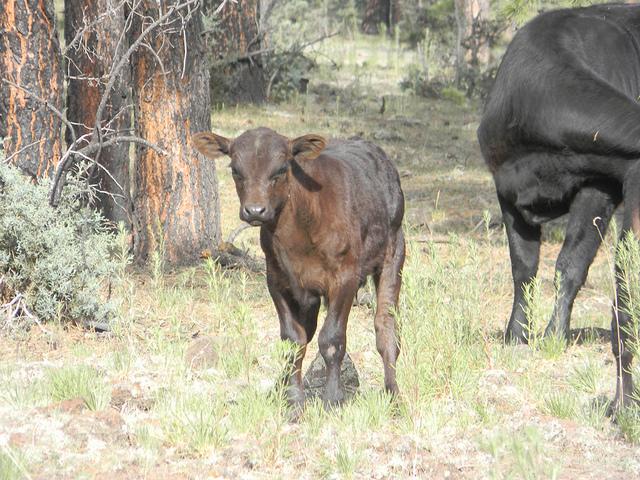What colors are the cows?
Quick response, please. Brown. What happened to the tree on the left?
Quick response, please. Burned. What animal is in the photo?
Concise answer only. Cow. Is there a newborn in this photo?
Quick response, please. Yes. 